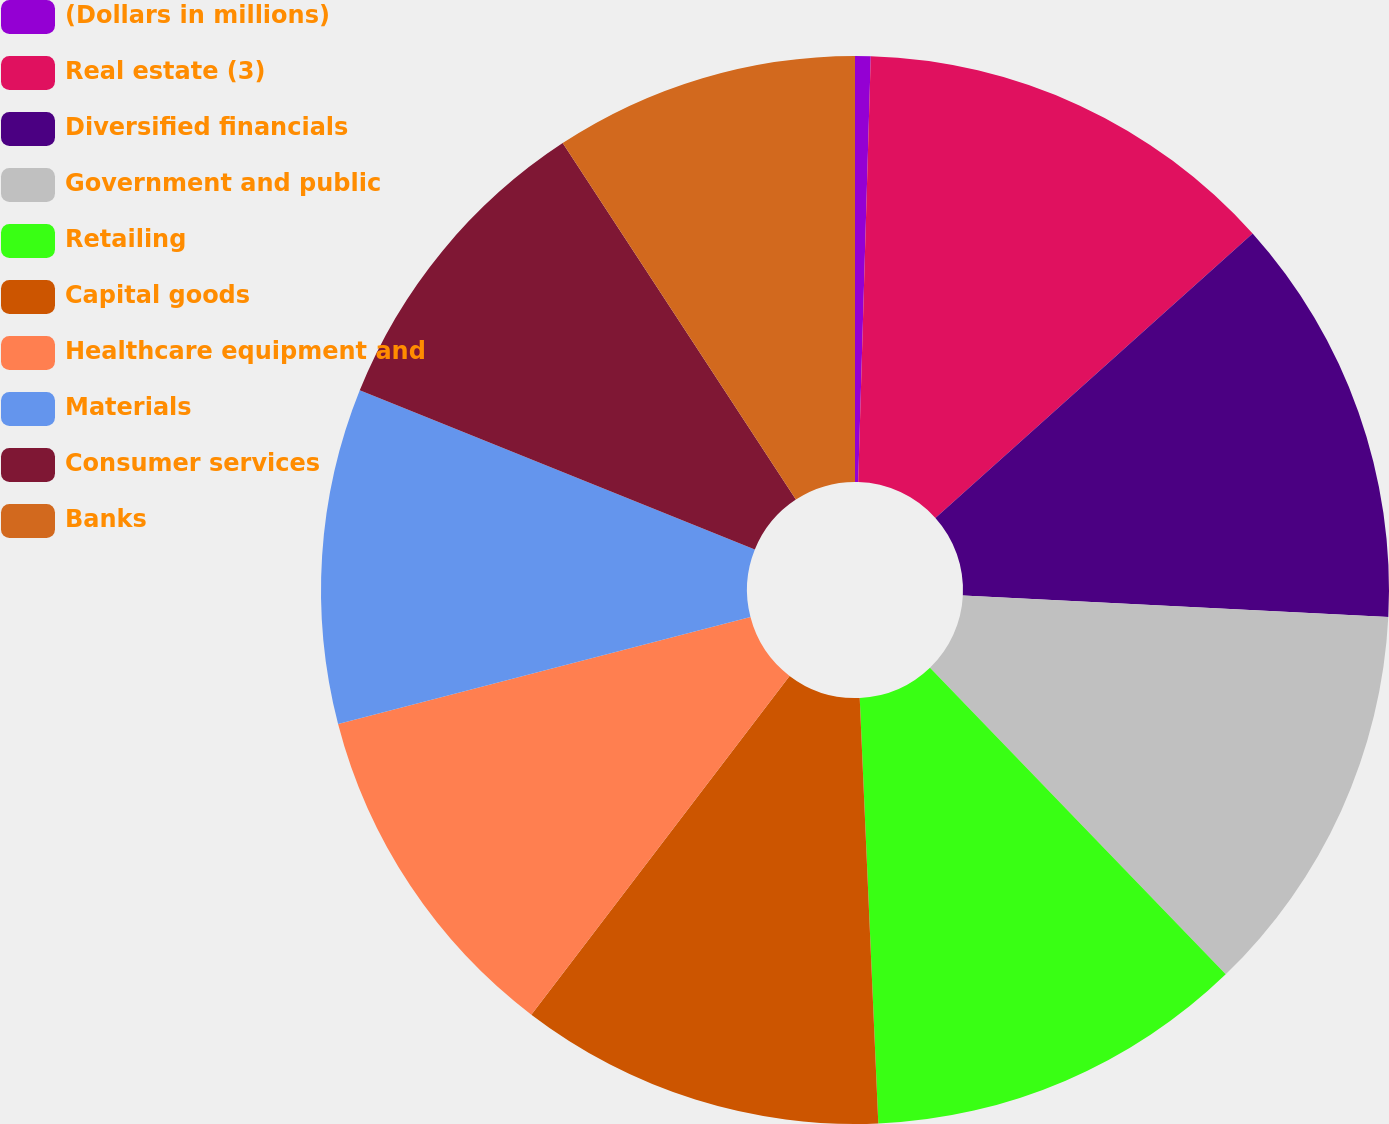Convert chart to OTSL. <chart><loc_0><loc_0><loc_500><loc_500><pie_chart><fcel>(Dollars in millions)<fcel>Real estate (3)<fcel>Diversified financials<fcel>Government and public<fcel>Retailing<fcel>Capital goods<fcel>Healthcare equipment and<fcel>Materials<fcel>Consumer services<fcel>Banks<nl><fcel>0.47%<fcel>12.9%<fcel>12.44%<fcel>11.98%<fcel>11.52%<fcel>11.06%<fcel>10.6%<fcel>10.14%<fcel>9.68%<fcel>9.22%<nl></chart> 